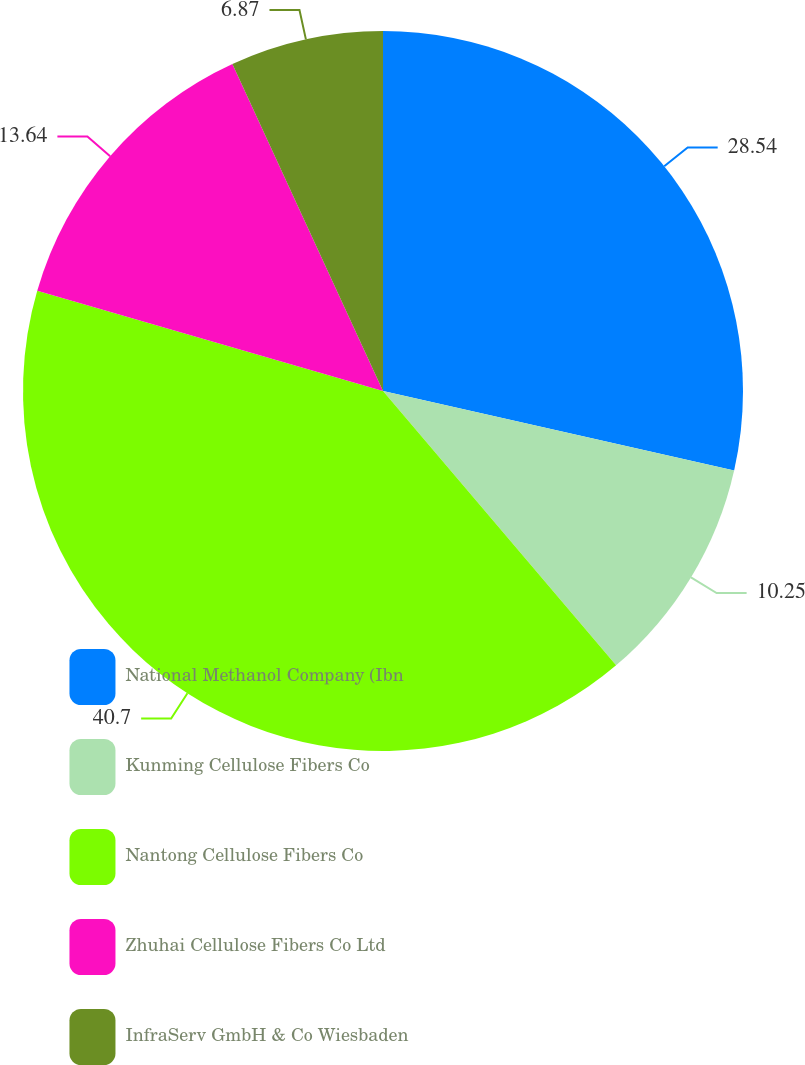Convert chart. <chart><loc_0><loc_0><loc_500><loc_500><pie_chart><fcel>National Methanol Company (Ibn<fcel>Kunming Cellulose Fibers Co<fcel>Nantong Cellulose Fibers Co<fcel>Zhuhai Cellulose Fibers Co Ltd<fcel>InfraServ GmbH & Co Wiesbaden<nl><fcel>28.54%<fcel>10.25%<fcel>40.7%<fcel>13.64%<fcel>6.87%<nl></chart> 